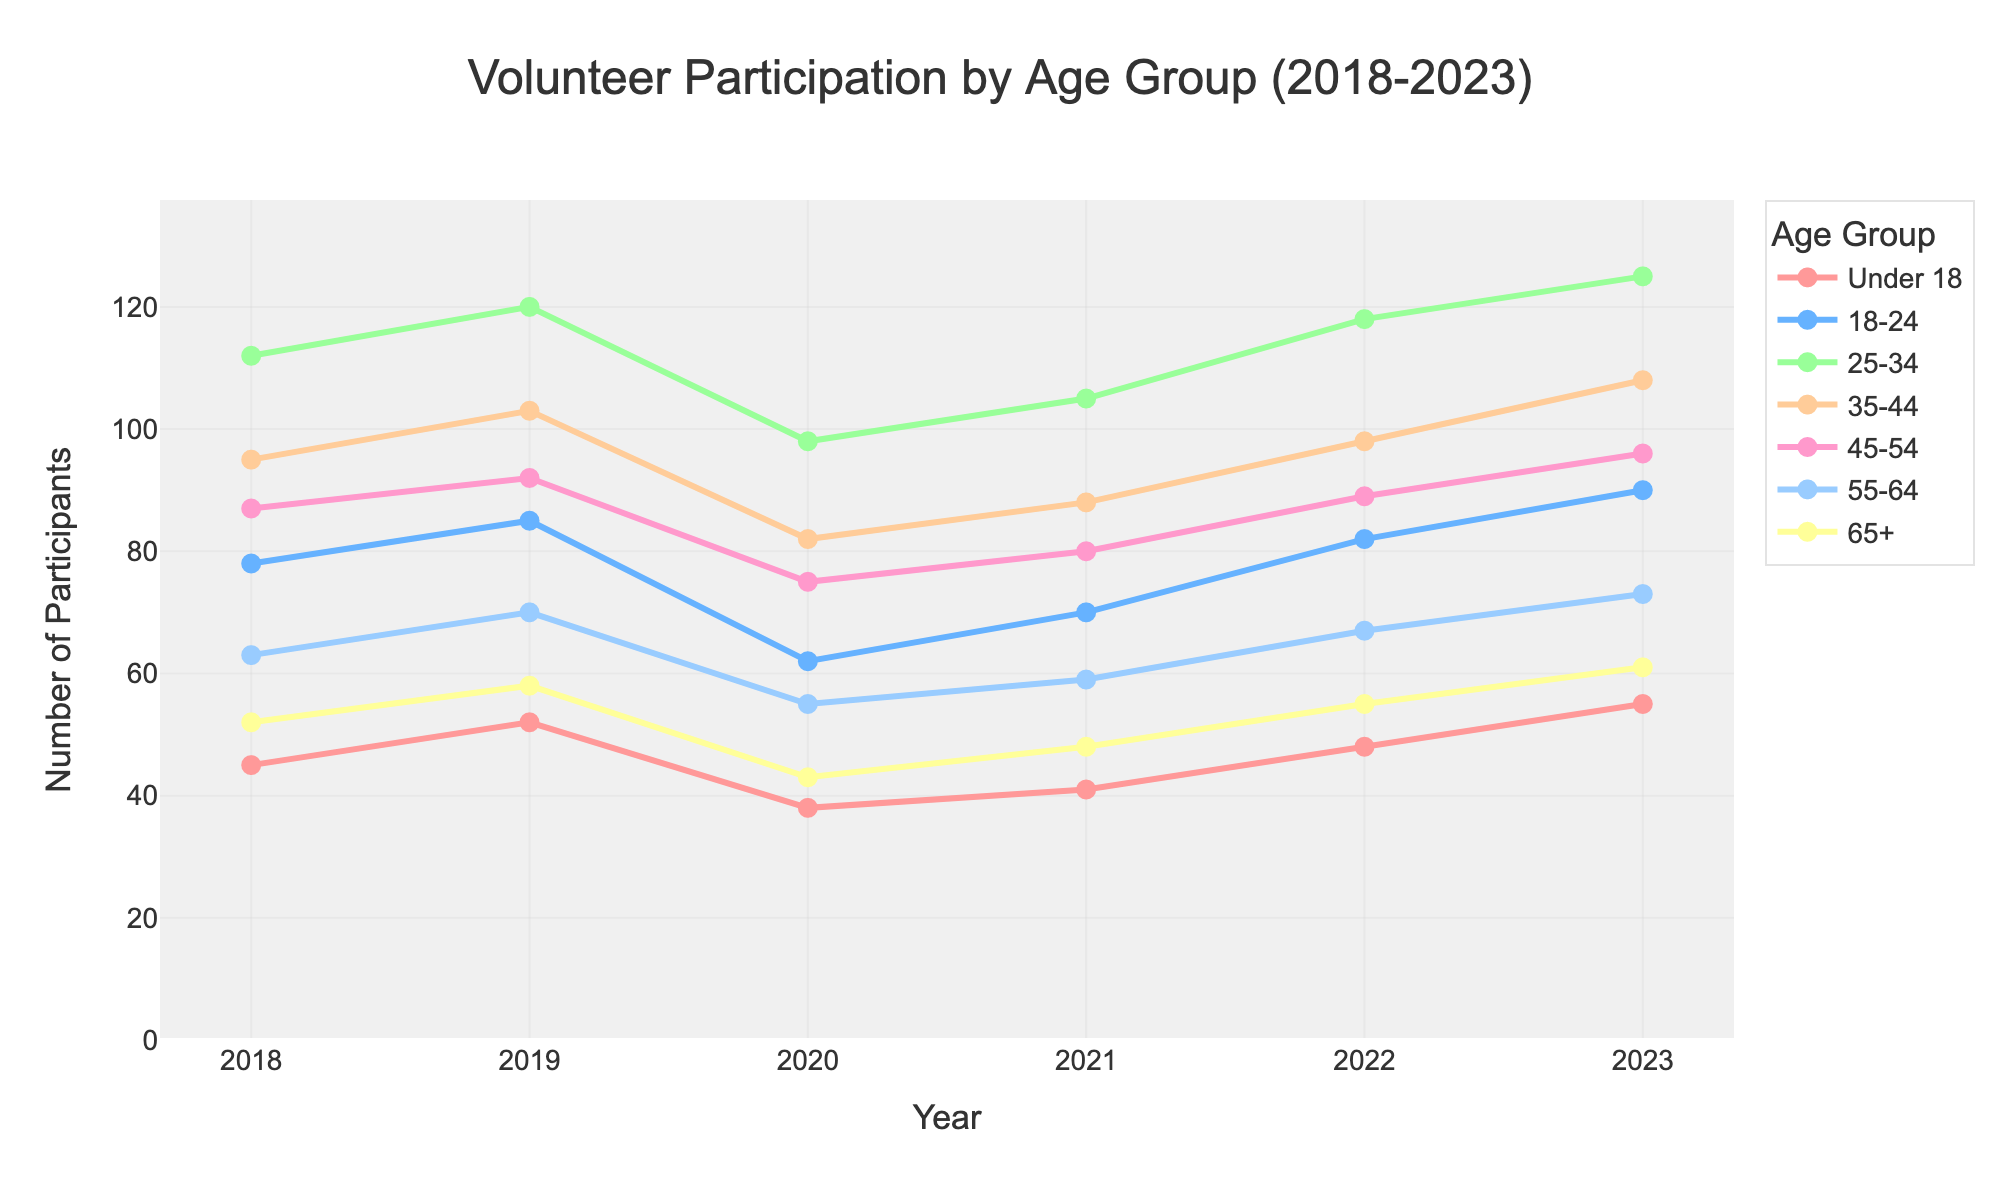How many participants were in the 18-24 age group in 2020? From the figure, locate the 18-24 age group line, find the data point for 2020, and read the value.
Answer: 62 Which age group had the highest number of participants in 2023? Compare the endpoints of each age group line for the year 2023 and identify the highest number.
Answer: 25-34 What is the overall trend of the number of participants in the 55-64 age group from 2018 to 2023? Observe the trajectory of the line representing the 55-64 age group from 2018 to 2023, noting whether it increases, decreases, or remains stable.
Answer: Increasing How did the number of participants in the 65+ age group change from 2018 to 2022? Find the starting point for 2018 and the endpoint for 2022 of the line for the 65+ age group; calculate the difference.
Answer: Increased by 3 Which age group had the smallest number of participants in 2019? Compare the data points of all age groups for the year 2019 and identify the smallest number.
Answer: Under 18 What is the average number of participants across all age groups for the year 2021? Sum the number of participants for each age group in 2021 and divide by the number of age groups (7). (41 + 70 + 105 + 88 + 80 + 59 + 48)/7 = 491/7 = 70.14
Answer: 70.14 Between 2019 and 2020, which age group saw the largest decrease in participation? Calculate the difference in participants for each age group between 2019 and 2020 and identify the largest negative difference. The differences are: Under 18: 52-38=14, 18-24: 85-62=23, 25-34: 120-98=22, 35-44: 103-82=21, 45-54: 92-75=17, 55-64: 70-55=15, 65+: 58-43=15
Answer: 18-24 By how much did the number of participants in the 25-34 age group increase from 2020 to 2023? Subtract the number of participants in 2020 from the number in 2023 for the 25-34 age group: 125 - 98 = 27
Answer: 27 Which age group showed the most consistent pattern of participation from 2018 to 2023? Determine which line has the least fluctuation in its path over the years.
Answer: 65+ In which year did the 35-44 age group experience the biggest increase in participants compared to the previous year? Compare the year-over-year differences for the 35-44 age group to find the largest increase. The differences are: 2018-2019 = 103-95=8, 2019-2020 = 82-103=-21, 2020-2021 = 88-82=6, 2021-2022 = 98-88=10, 2022-2023 = 108-98=10. Both 2021-2022 and 2022-2023 show an increase of 10.
Answer: 2022 and 2023 